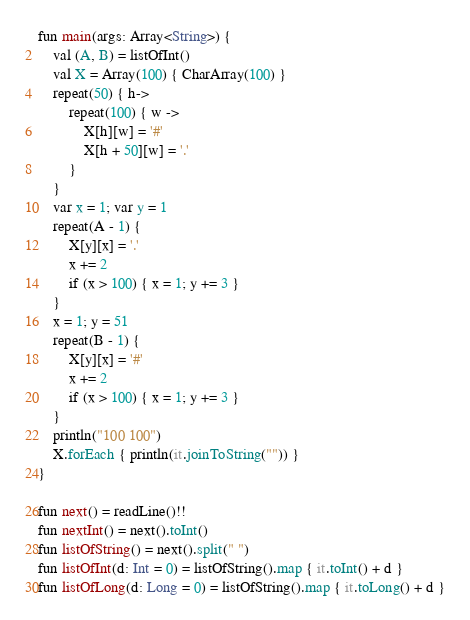Convert code to text. <code><loc_0><loc_0><loc_500><loc_500><_Kotlin_>fun main(args: Array<String>) {
    val (A, B) = listOfInt()
    val X = Array(100) { CharArray(100) }
    repeat(50) { h->
        repeat(100) { w ->
            X[h][w] = '#'
            X[h + 50][w] = '.'
        }
    }
    var x = 1; var y = 1
    repeat(A - 1) {
        X[y][x] = '.'
        x += 2
        if (x > 100) { x = 1; y += 3 }
    }
    x = 1; y = 51
    repeat(B - 1) {
        X[y][x] = '#'
        x += 2
        if (x > 100) { x = 1; y += 3 }
    }
    println("100 100")
    X.forEach { println(it.joinToString("")) }
}

fun next() = readLine()!!
fun nextInt() = next().toInt()
fun listOfString() = next().split(" ")
fun listOfInt(d: Int = 0) = listOfString().map { it.toInt() + d }
fun listOfLong(d: Long = 0) = listOfString().map { it.toLong() + d }

</code> 